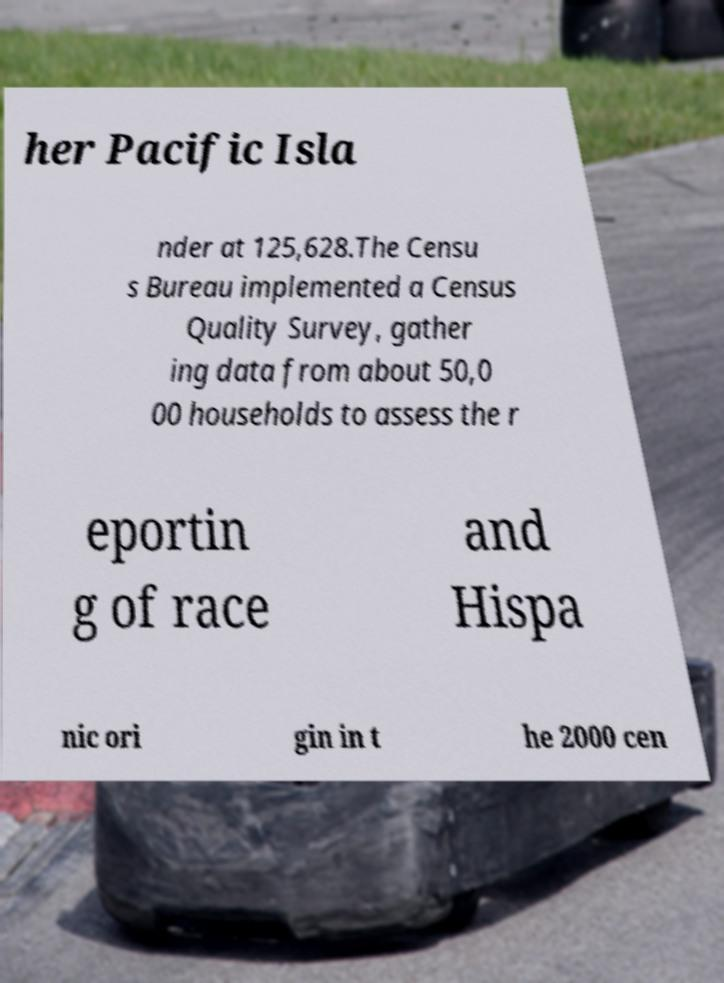Can you accurately transcribe the text from the provided image for me? her Pacific Isla nder at 125,628.The Censu s Bureau implemented a Census Quality Survey, gather ing data from about 50,0 00 households to assess the r eportin g of race and Hispa nic ori gin in t he 2000 cen 